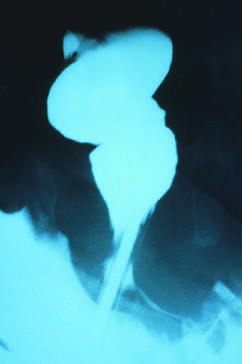were all three transverse sections of myocardium absent in the rectum, but presented in the sigmoid colon?
Answer the question using a single word or phrase. No 